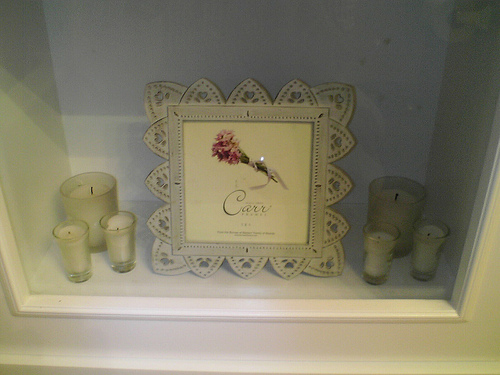<image>
Is there a candle under the photo frame? No. The candle is not positioned under the photo frame. The vertical relationship between these objects is different. 